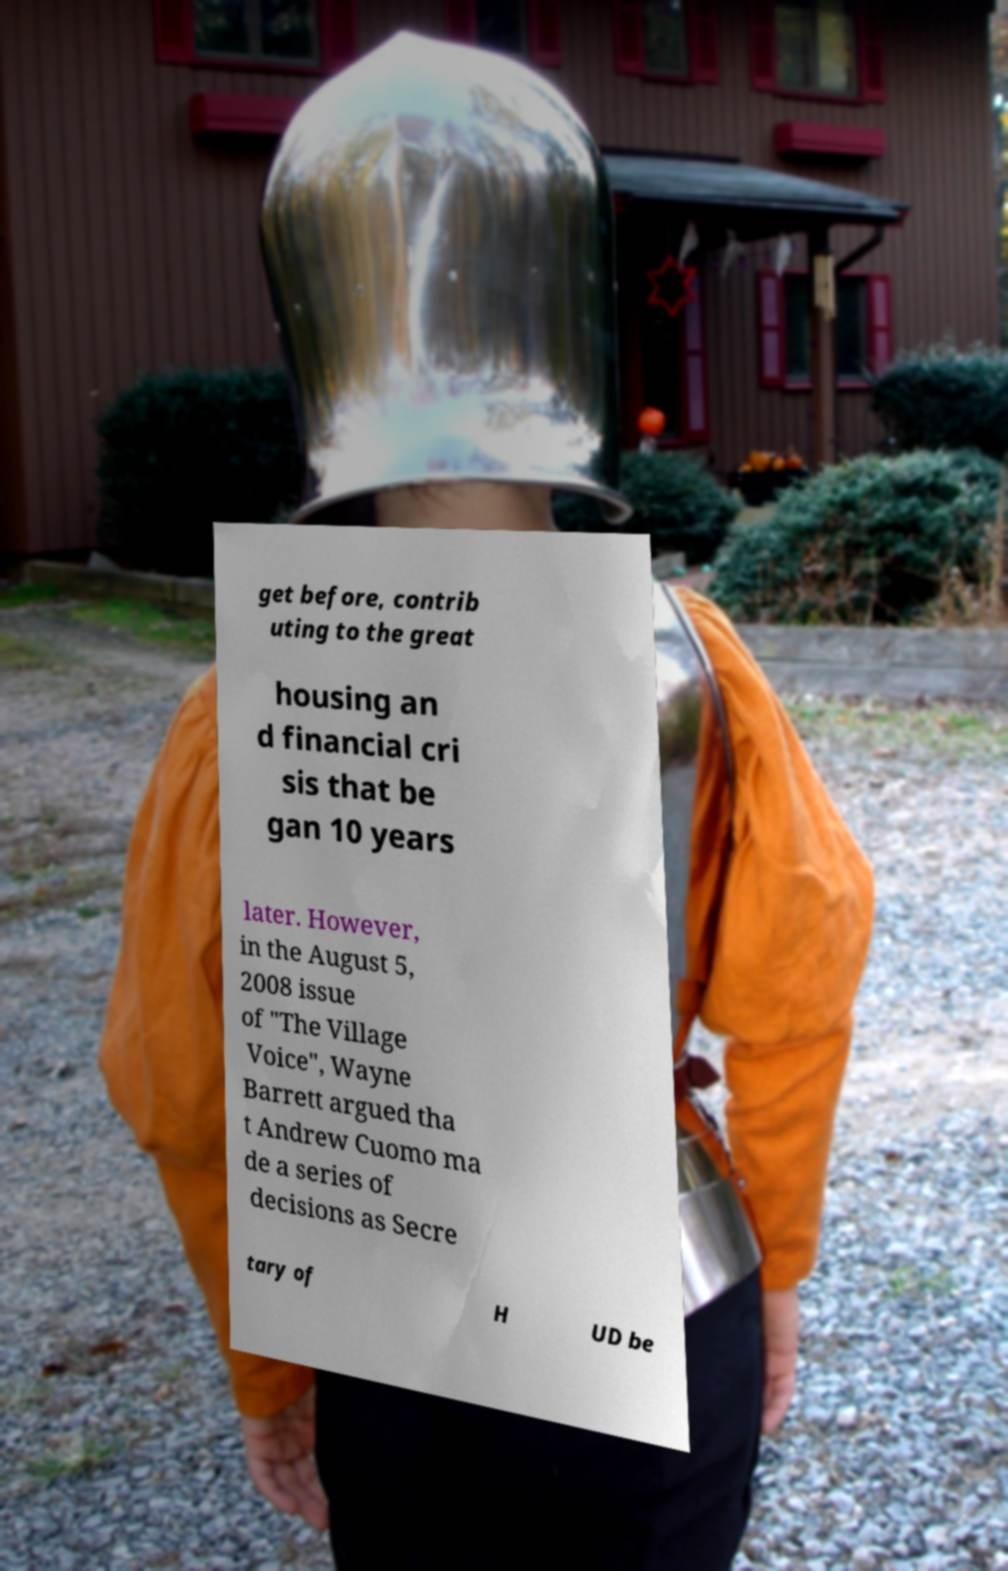What messages or text are displayed in this image? I need them in a readable, typed format. get before, contrib uting to the great housing an d financial cri sis that be gan 10 years later. However, in the August 5, 2008 issue of "The Village Voice", Wayne Barrett argued tha t Andrew Cuomo ma de a series of decisions as Secre tary of H UD be 